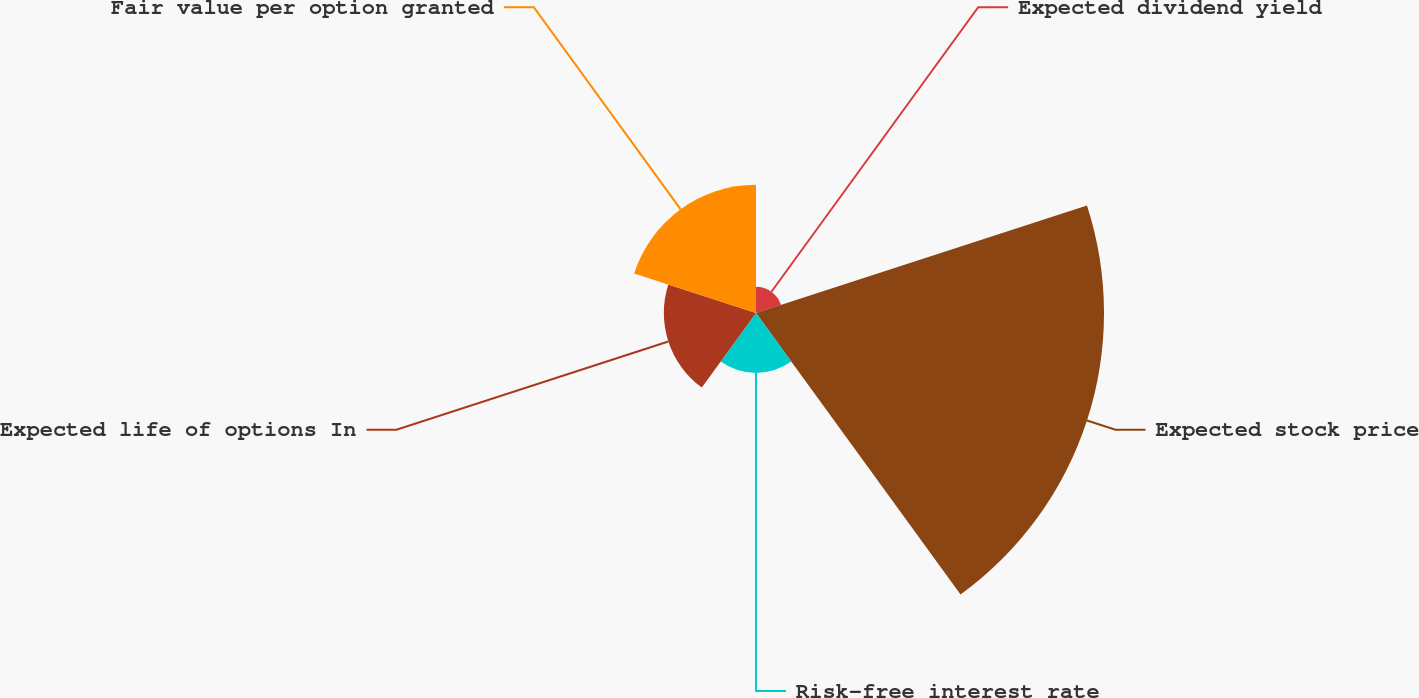<chart> <loc_0><loc_0><loc_500><loc_500><pie_chart><fcel>Expected dividend yield<fcel>Expected stock price<fcel>Risk-free interest rate<fcel>Expected life of options In<fcel>Fair value per option granted<nl><fcel>4.01%<fcel>53.17%<fcel>9.16%<fcel>14.08%<fcel>19.58%<nl></chart> 